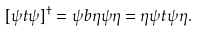Convert formula to latex. <formula><loc_0><loc_0><loc_500><loc_500>[ \psi t \psi ] ^ { \dagger } = \psi b \eta \psi \eta = \eta \psi t \psi \eta .</formula> 